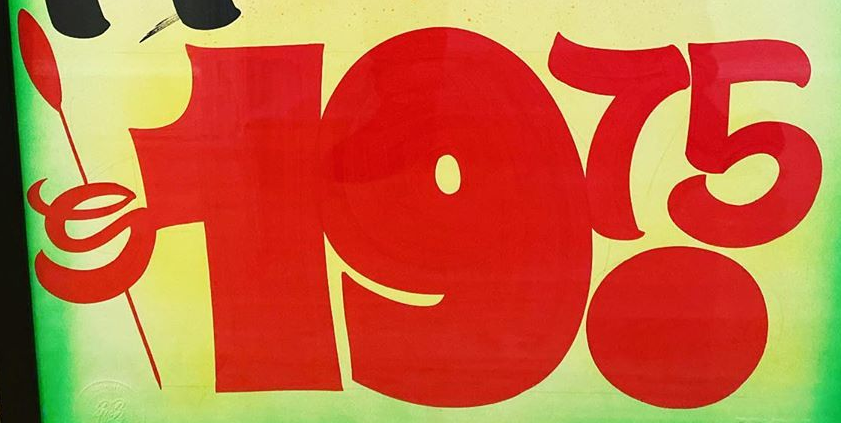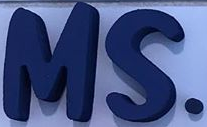What words can you see in these images in sequence, separated by a semicolon? $19.75; MS. 